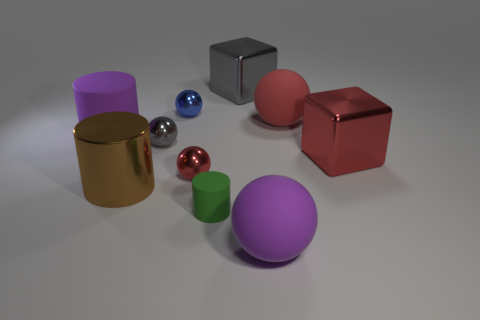There is a big metallic thing behind the cube that is in front of the large gray object; what shape is it?
Offer a very short reply. Cube. Is there anything else that is the same color as the big matte cylinder?
Offer a very short reply. Yes. How many yellow things are either small matte cylinders or cubes?
Offer a very short reply. 0. Is the number of large spheres that are to the left of the green cylinder less than the number of green rubber cylinders?
Provide a short and direct response. Yes. There is a big cube that is on the right side of the large purple matte ball; what number of brown metallic cylinders are left of it?
Provide a short and direct response. 1. How many other objects are there of the same size as the blue thing?
Your answer should be compact. 3. What number of things are either tiny blocks or large metal cubes that are in front of the tiny blue sphere?
Your answer should be very brief. 1. Are there fewer big cyan metallic blocks than small gray balls?
Keep it short and to the point. Yes. There is a big ball behind the red metallic object that is on the right side of the small red sphere; what is its color?
Your response must be concise. Red. What is the material of the large red object that is the same shape as the tiny blue shiny object?
Give a very brief answer. Rubber. 